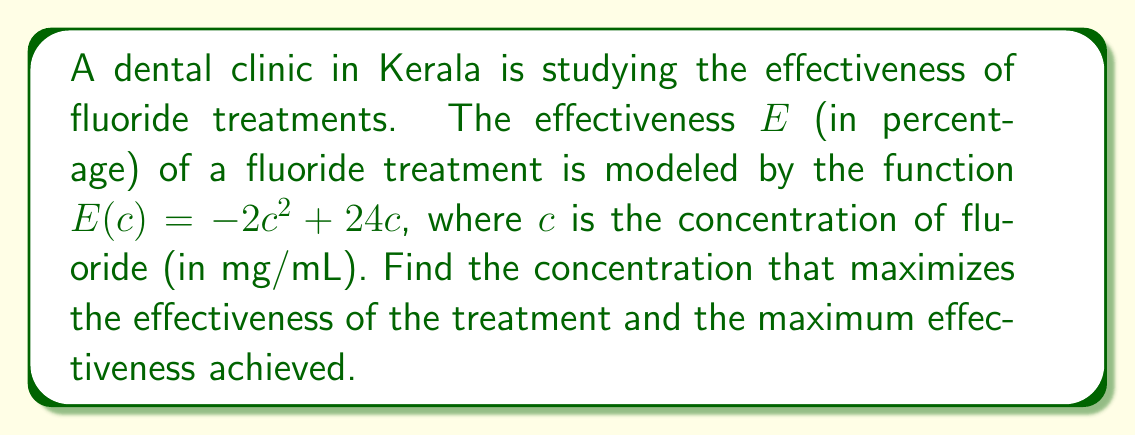Solve this math problem. To find the maximum effectiveness, we need to find the maximum value of the function $E(c) = -2c^2 + 24c$. This can be done using calculus:

1) First, find the derivative of $E(c)$:
   $$E'(c) = -4c + 24$$

2) Set the derivative equal to zero to find the critical point:
   $$-4c + 24 = 0$$
   $$-4c = -24$$
   $$c = 6$$

3) To confirm this is a maximum, check the second derivative:
   $$E''(c) = -4$$
   Since $E''(c)$ is negative, the critical point is indeed a maximum.

4) The optimal concentration is therefore 6 mg/mL.

5) To find the maximum effectiveness, substitute $c = 6$ into the original function:
   $$E(6) = -2(6)^2 + 24(6)$$
   $$= -2(36) + 144$$
   $$= -72 + 144$$
   $$= 72$$

Therefore, the maximum effectiveness is 72%.
Answer: Optimal concentration: 6 mg/mL; Maximum effectiveness: 72% 